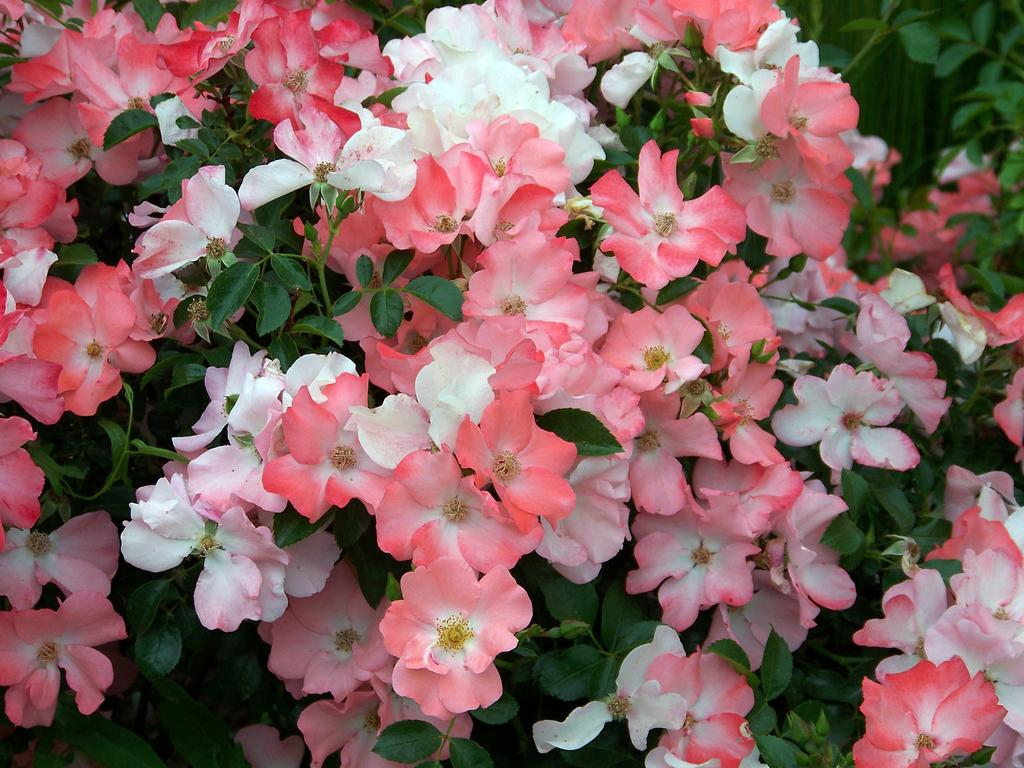What types of flowers are present in the image? There are beautiful pink and white flowers in the image. Are the flowers attached to any plants or stems? Yes, the flowers are on plants. How much salt is present in the image? There is no salt present in the image; it features flowers on plants. What color are the eyes of the flowers in the image? The flowers in the image do not have eyes, as they are inanimate objects. 